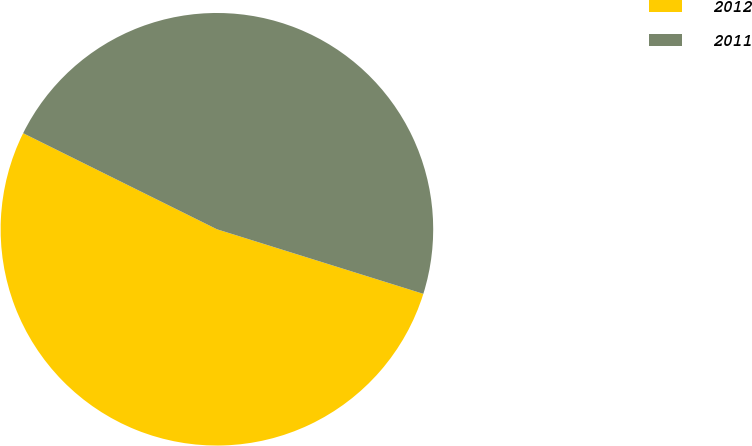Convert chart to OTSL. <chart><loc_0><loc_0><loc_500><loc_500><pie_chart><fcel>2012<fcel>2011<nl><fcel>52.5%<fcel>47.5%<nl></chart> 